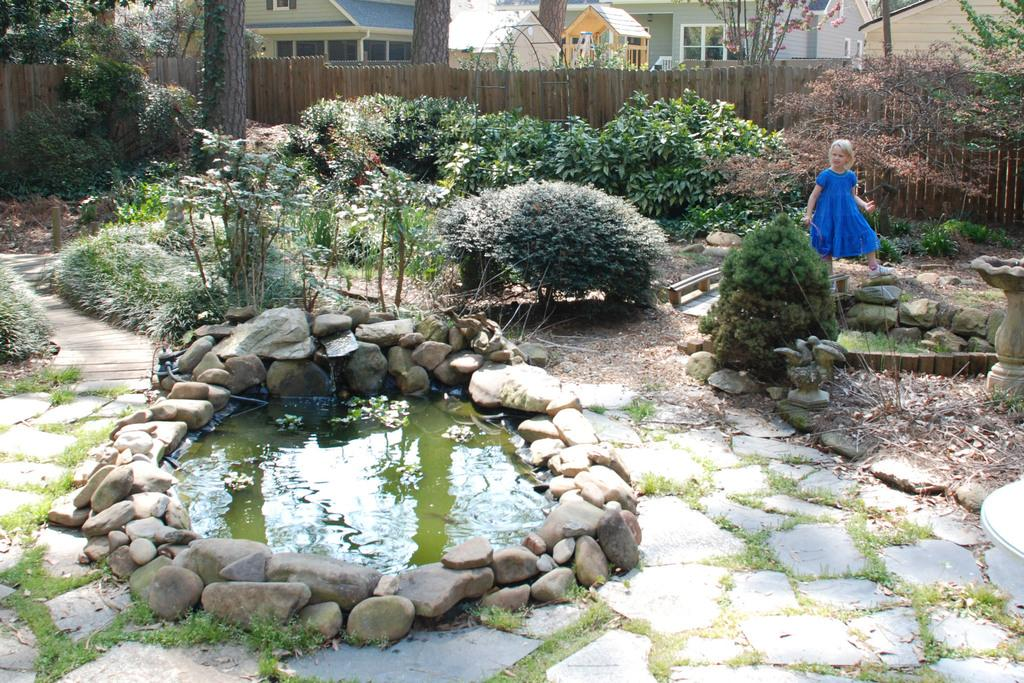Who is in the image? There is a girl in the image. What is visible in the image besides the girl? Water, rocks, a pedestal, grass, plants, a fence, trees, and houses in the background are visible in the image. Can you describe the setting of the image? The image features a natural environment with water, rocks, grass, plants, and trees, as well as a fence and houses in the background. What might the girl be interacting with in the image? The girl might be interacting with the pedestal, which is present in the image. What type of whip can be seen in the girl's hand in the image? There is no whip present in the image; the girl's hands are not visible. What ingredients are used to make the stew in the image? There is no stew present in the image; the focus is on the girl and the natural environment. 